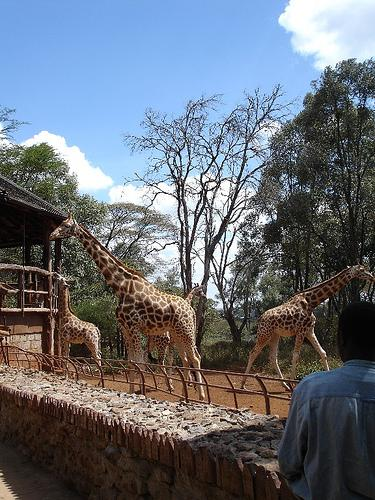What prevents the Giraffes from escaping the fence?

Choices:
A) material
B) color
C) it's width
D) texture it's width 